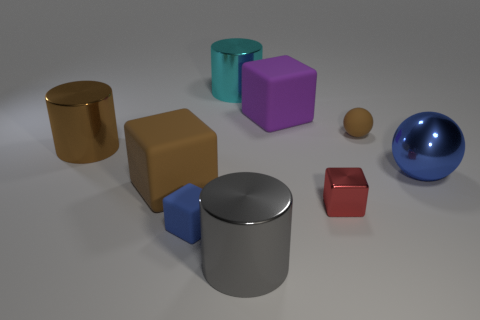There is a matte object that is the same color as the tiny sphere; what shape is it?
Offer a terse response. Cube. How many gray shiny things are on the right side of the ball on the left side of the blue thing that is right of the tiny shiny thing?
Offer a very short reply. 0. There is a metallic thing that is both left of the large gray metal cylinder and in front of the purple rubber object; what is its shape?
Your answer should be compact. Cylinder. Is the number of large brown things in front of the big blue metallic object less than the number of tiny matte spheres?
Your response must be concise. No. What number of small objects are gray metal cylinders or cyan objects?
Give a very brief answer. 0. How big is the matte sphere?
Your answer should be very brief. Small. What number of small metallic objects are right of the blue sphere?
Your answer should be compact. 0. There is a cyan metal thing that is the same shape as the gray shiny object; what is its size?
Provide a short and direct response. Large. There is a object that is to the left of the large purple object and behind the small brown rubber sphere; how big is it?
Provide a succinct answer. Large. There is a big ball; is it the same color as the matte block that is behind the big blue object?
Make the answer very short. No. 